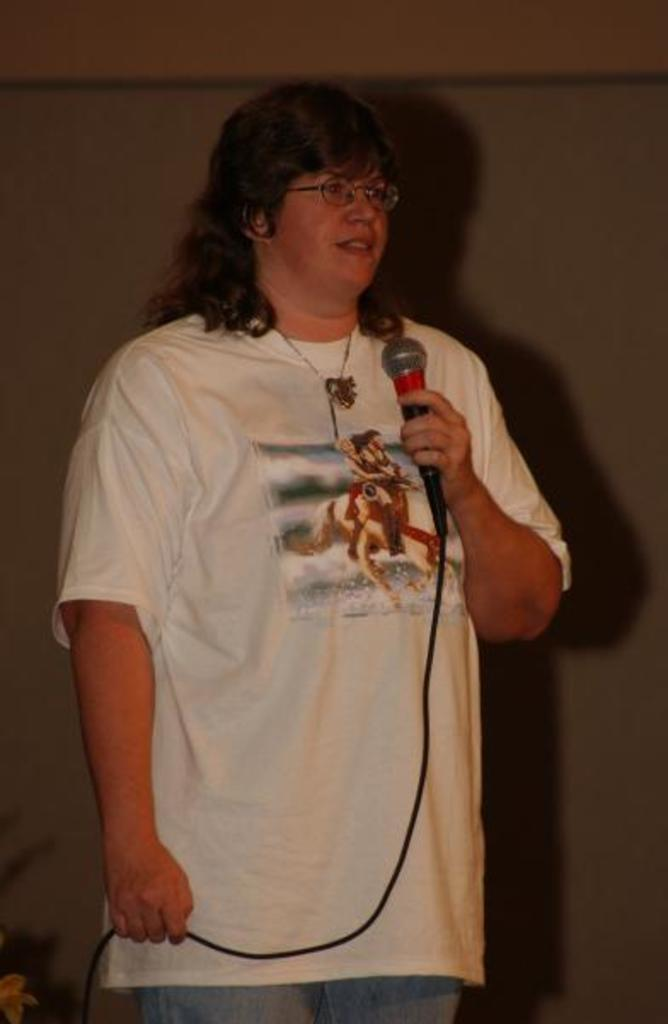Who is the main subject in the image? There is a woman in the image. What is the woman wearing? The woman is wearing a white t-shirt. What is the woman holding in her hand? The woman is holding a microphone in her hand. What is the woman doing in the image? The woman is speaking. What can be seen behind the woman in the image? There is a wall behind the woman. What purpose does the lumber serve in the image? There is no lumber present in the image. Can you tell me how many calculators are visible in the image? There are no calculators visible in the image. 